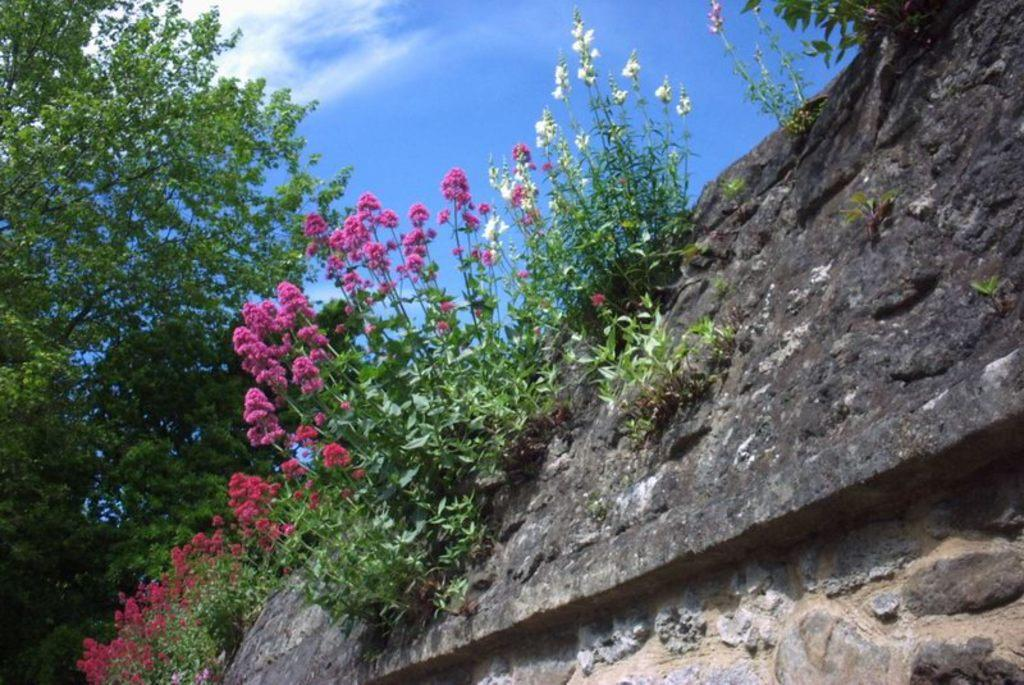What colors are the flowers on the plants in the image? The flowers on the plants are pink and white. What type of vegetation can be seen in the image? There are trees in the image. What is located in the foreground of the image? There is a wall in the foreground of the image. What is visible at the top of the image? The sky is visible at the top of the image. What can be seen in the sky-wise in the image? There are clouds in the sky. How many chickens are crossing the road in the image? There are no chickens or roads present in the image. 